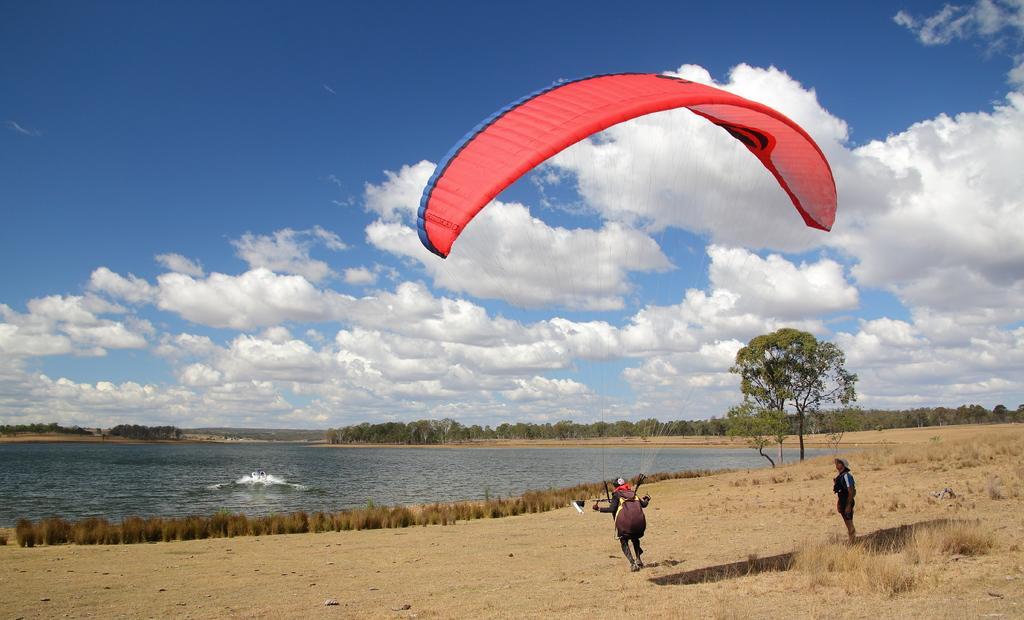In one or two sentences, can you explain what this image depicts? In this picture there is a man holding red color parachute, standing on the dry ground. Beside there is a another man standing and looking him. Behind there is a small pond water and some trees. 